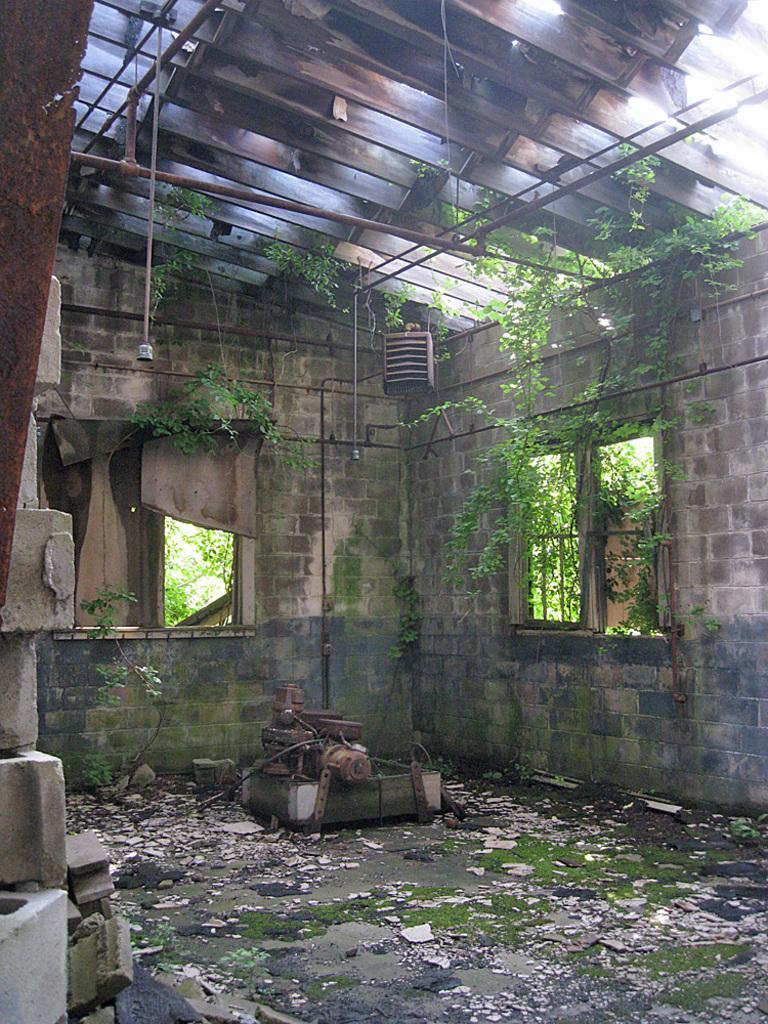How would you summarize this image in a sentence or two? In this picture there is a inside view of the damage room. In the front we can see the wall and windows. On the top there is a hanging lights and shed roof. 